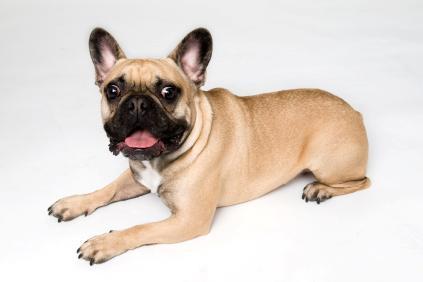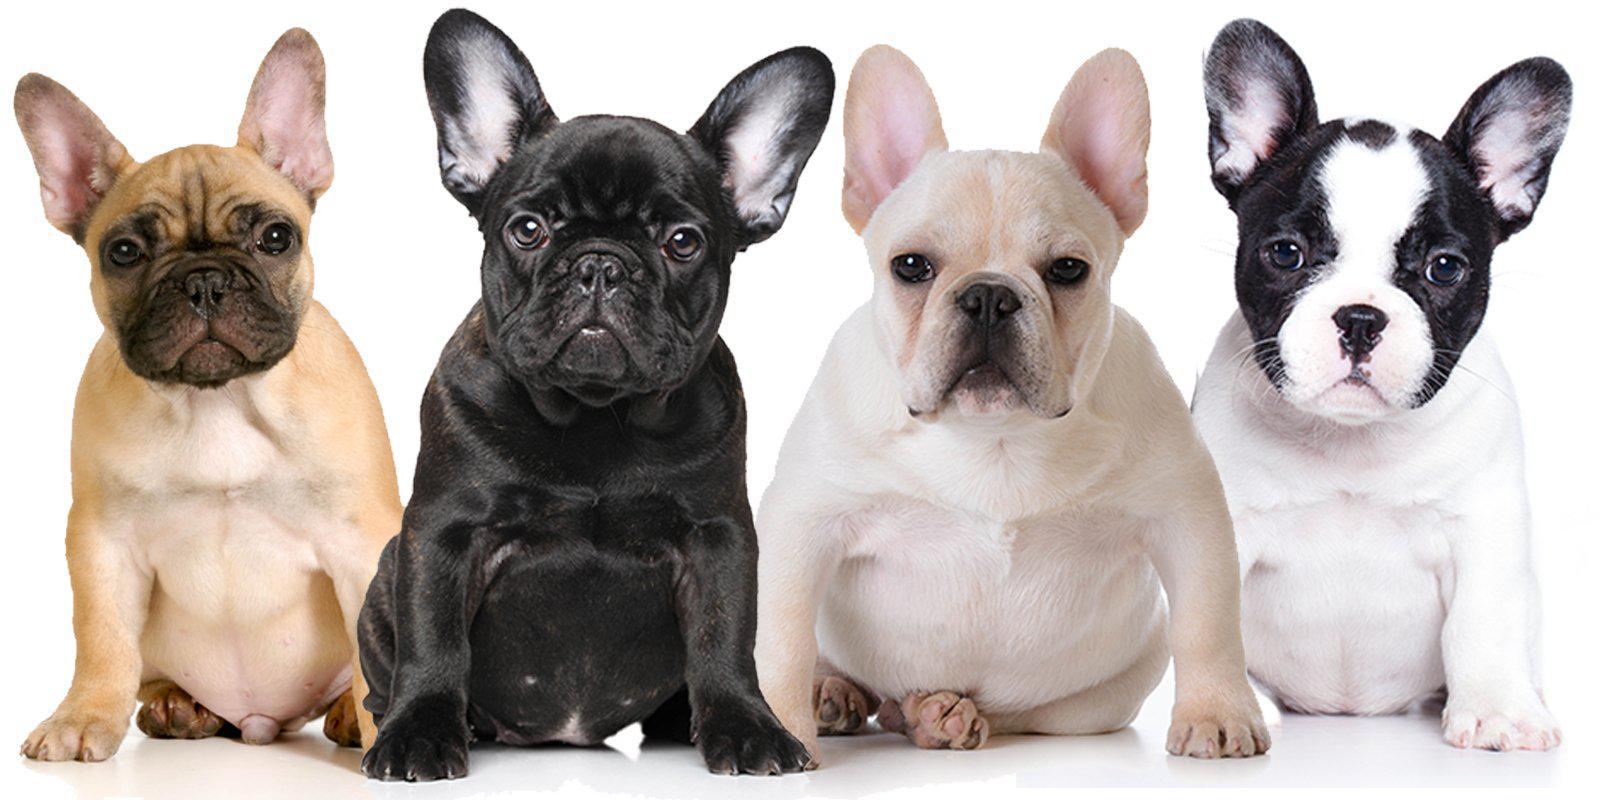The first image is the image on the left, the second image is the image on the right. Analyze the images presented: Is the assertion "In the left image, a french bull dog puppy is standing and facing toward the right" valid? Answer yes or no. No. The first image is the image on the left, the second image is the image on the right. Examine the images to the left and right. Is the description "there are 4 togs in total" accurate? Answer yes or no. No. 